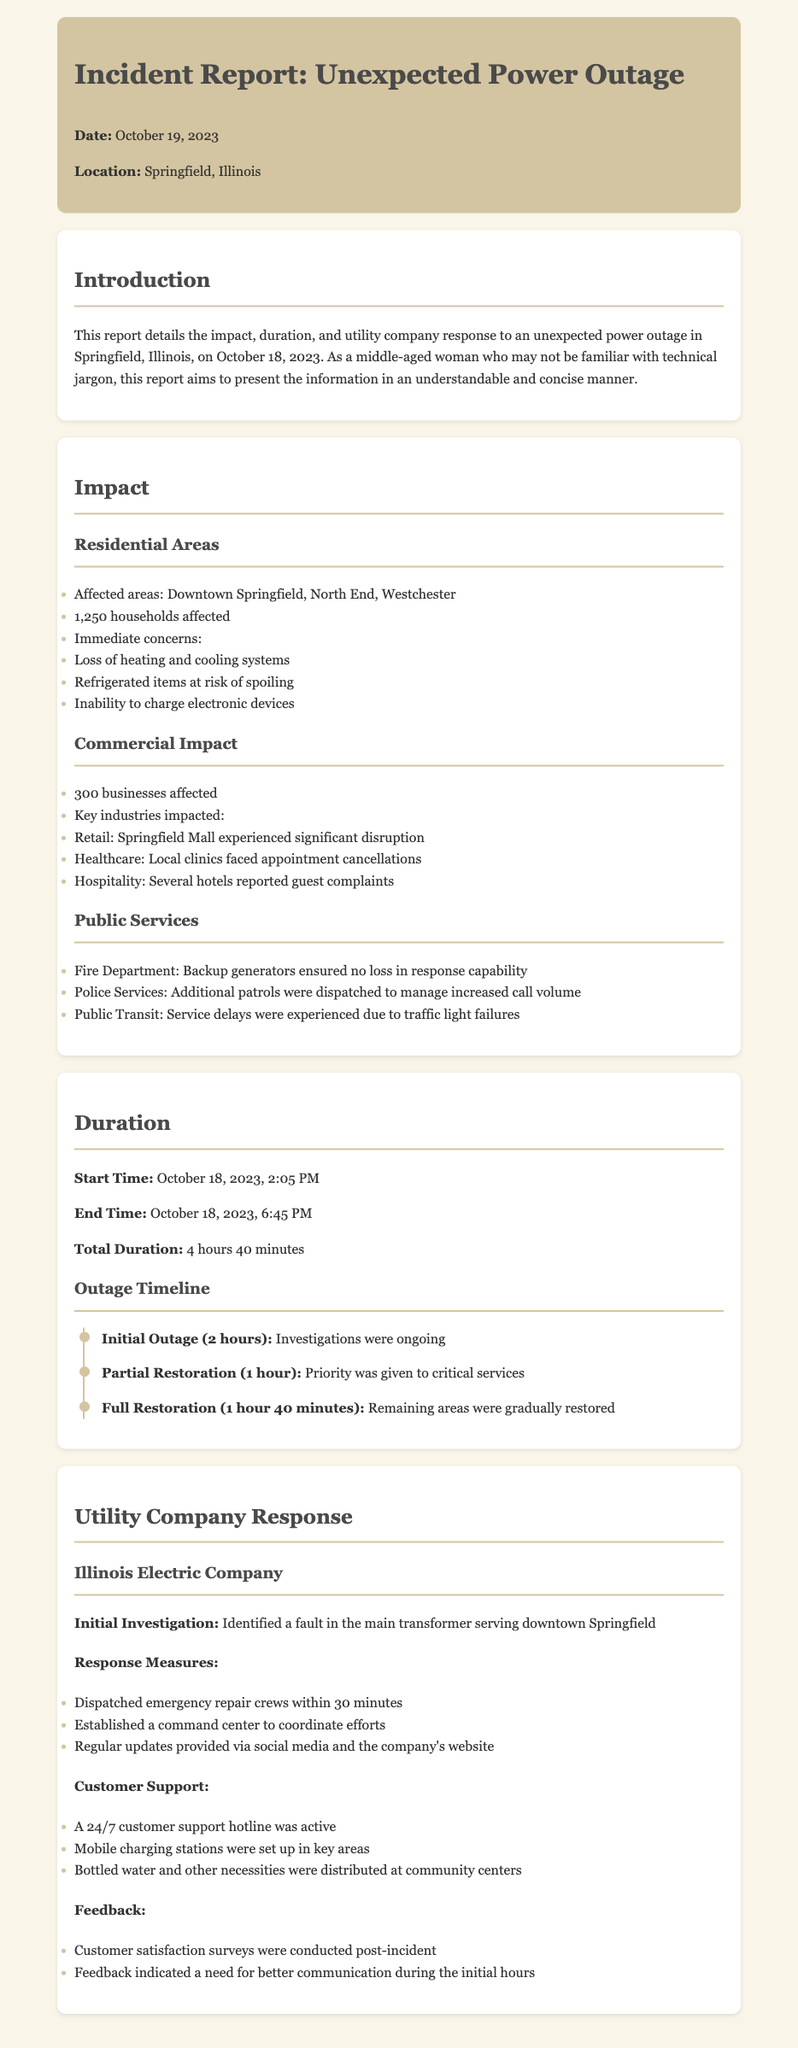What date did the power outage occur? The report states the power outage occurred on October 18, 2023.
Answer: October 18, 2023 How many households were affected by the outage? The document specifies that 1,250 households were affected.
Answer: 1,250 households What was the total duration of the power outage? The report mentions a total duration of 4 hours 40 minutes.
Answer: 4 hours 40 minutes What location did the power outage primarily impact? The report lists Springfield, Illinois as the location affected by the outage.
Answer: Springfield, Illinois What was one of the immediate concerns for households? The report highlights the risk of refrigerated items spoiling as an immediate concern.
Answer: Risk of spoiling refrigerated items Who provided customer support during the outage? The document states that Illinois Electric Company provided customer support.
Answer: Illinois Electric Company How long did the initial outage last before partial restoration? The report indicates that the initial outage lasted for 2 hours before partial restoration began.
Answer: 2 hours What measures did the utility company take for their response? The report outlines that they dispatched emergency repair crews and set up a command center as response measures.
Answer: Dispatched emergency repair crews What feedback was indicated from customer satisfaction surveys? The document mentions that there was a need for better communication during the initial hours according to the feedback.
Answer: Need for better communication during the initial hours 